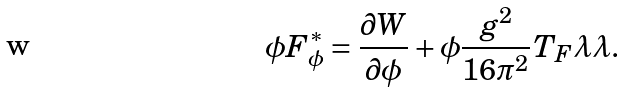<formula> <loc_0><loc_0><loc_500><loc_500>\phi F _ { \phi } ^ { * } = \frac { \partial W } { \partial \phi } + \phi \frac { g ^ { 2 } } { 1 6 \pi ^ { 2 } } T _ { F } \lambda \lambda .</formula> 